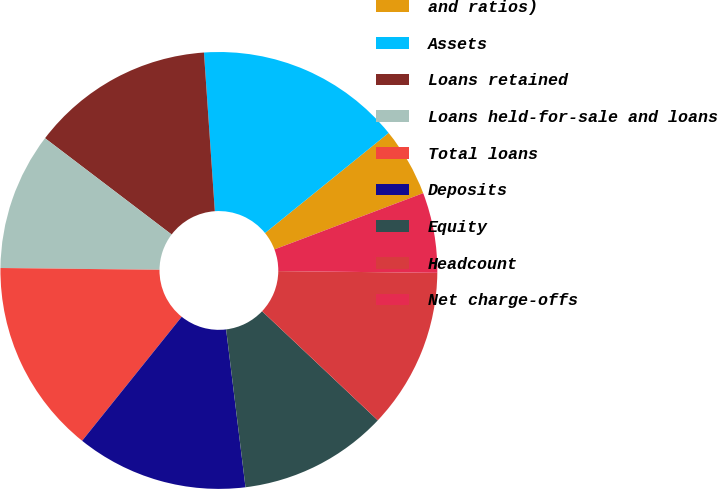Convert chart. <chart><loc_0><loc_0><loc_500><loc_500><pie_chart><fcel>and ratios)<fcel>Assets<fcel>Loans retained<fcel>Loans held-for-sale and loans<fcel>Total loans<fcel>Deposits<fcel>Equity<fcel>Headcount<fcel>Net charge-offs<nl><fcel>5.08%<fcel>15.25%<fcel>13.56%<fcel>10.17%<fcel>14.41%<fcel>12.71%<fcel>11.02%<fcel>11.86%<fcel>5.93%<nl></chart> 